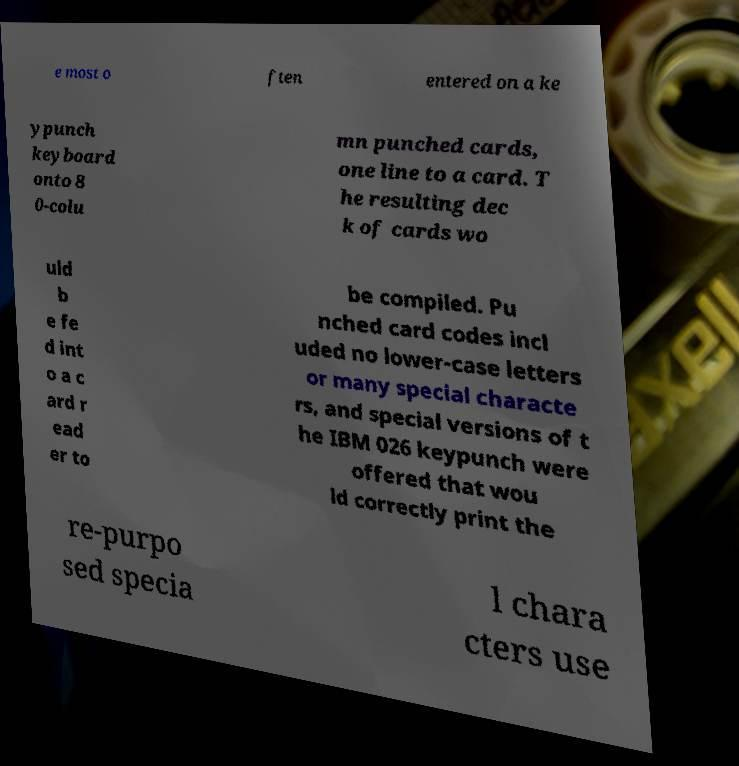Please read and relay the text visible in this image. What does it say? e most o ften entered on a ke ypunch keyboard onto 8 0-colu mn punched cards, one line to a card. T he resulting dec k of cards wo uld b e fe d int o a c ard r ead er to be compiled. Pu nched card codes incl uded no lower-case letters or many special characte rs, and special versions of t he IBM 026 keypunch were offered that wou ld correctly print the re-purpo sed specia l chara cters use 